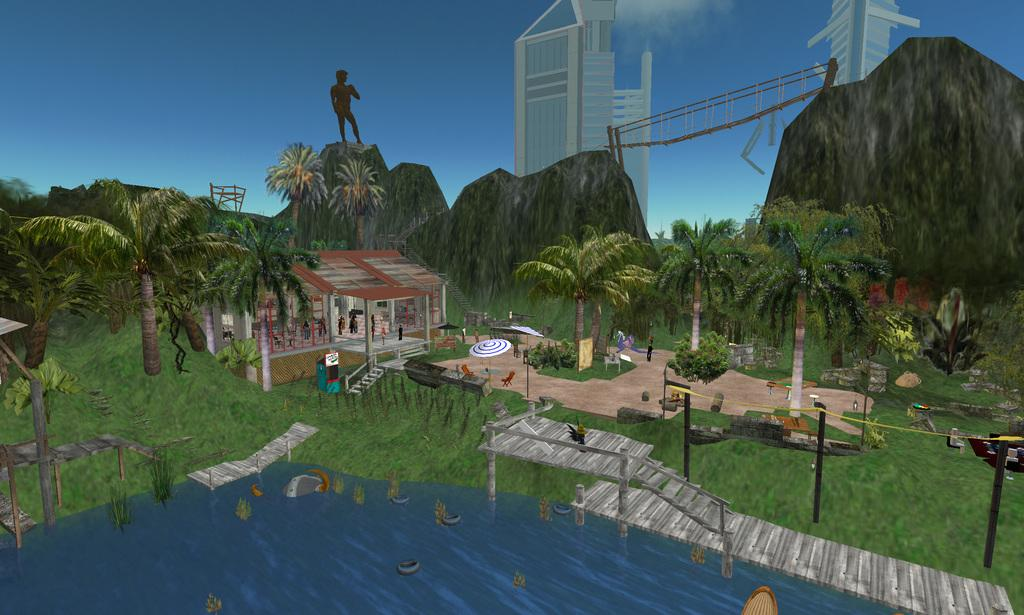What natural element is present in the painting? The painting contains water. What type of objects can be seen in the painting? The painting contains wooden objects. What living beings are depicted in the painting? The painting contains people. What type of structure is present in the painting? The painting contains a building. What type of vegetation is present in the painting? The painting contains trees. What geographical feature is present in the painting? The painting contains mountains. What man-made structure is present in the painting? The painting contains a bridge. How many worms can be seen crawling on the wooden objects in the painting? There are no worms present in the painting; it contains wooden objects, but no worms. What type of division is depicted in the painting? There is no division depicted in the painting; it contains various elements such as water, people, buildings, trees, mountains, and a bridge, but no division. 